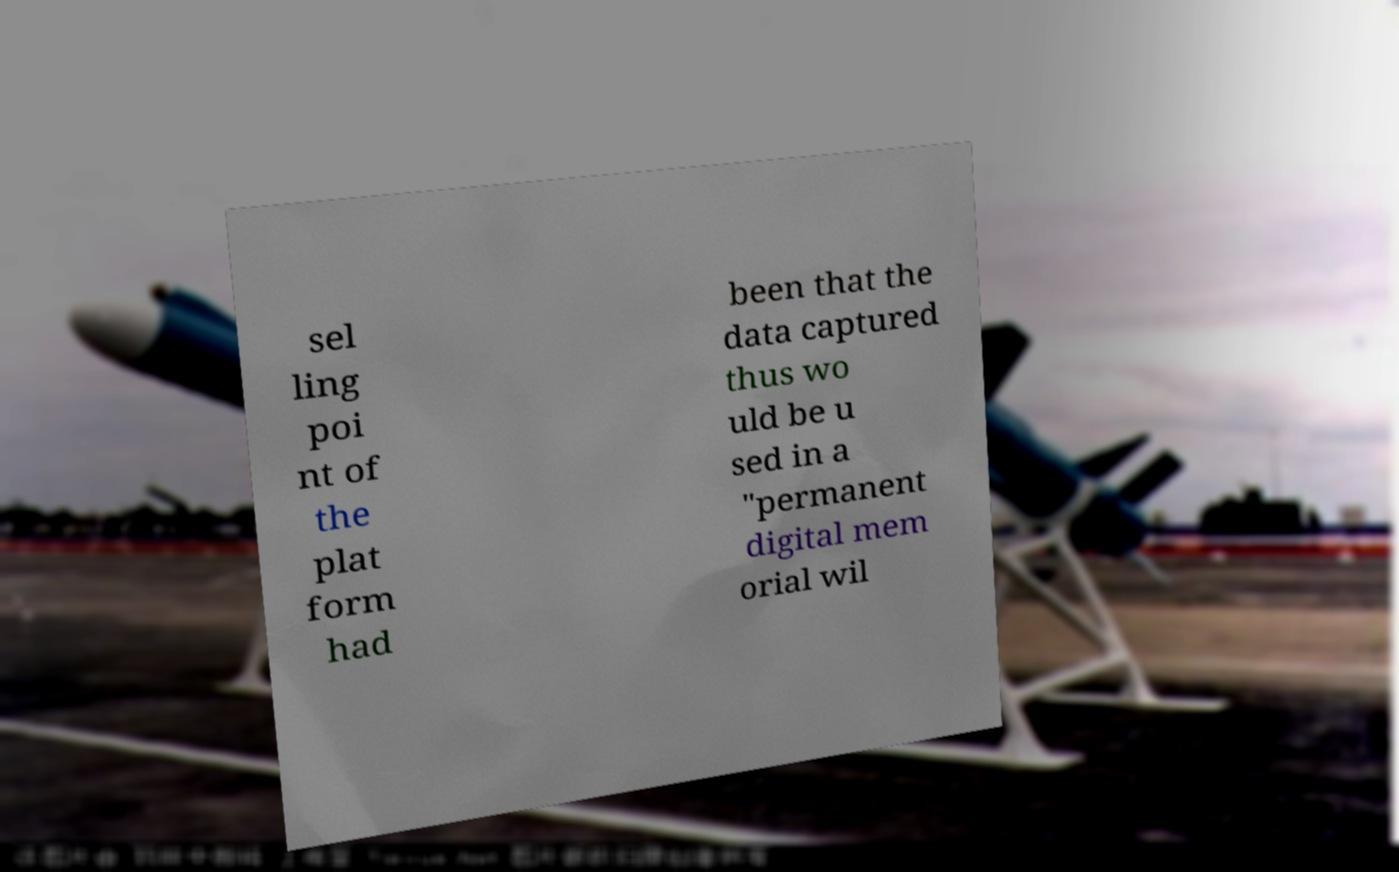Can you read and provide the text displayed in the image?This photo seems to have some interesting text. Can you extract and type it out for me? sel ling poi nt of the plat form had been that the data captured thus wo uld be u sed in a "permanent digital mem orial wil 